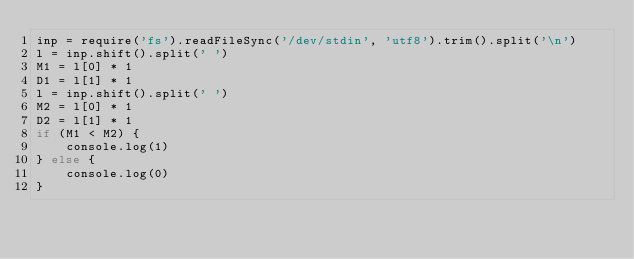Convert code to text. <code><loc_0><loc_0><loc_500><loc_500><_JavaScript_>inp = require('fs').readFileSync('/dev/stdin', 'utf8').trim().split('\n')
l = inp.shift().split(' ')
M1 = l[0] * 1
D1 = l[1] * 1 
l = inp.shift().split(' ')
M2 = l[0] * 1
D2 = l[1] * 1 
if (M1 < M2) {
    console.log(1)
} else {
    console.log(0)
}
</code> 